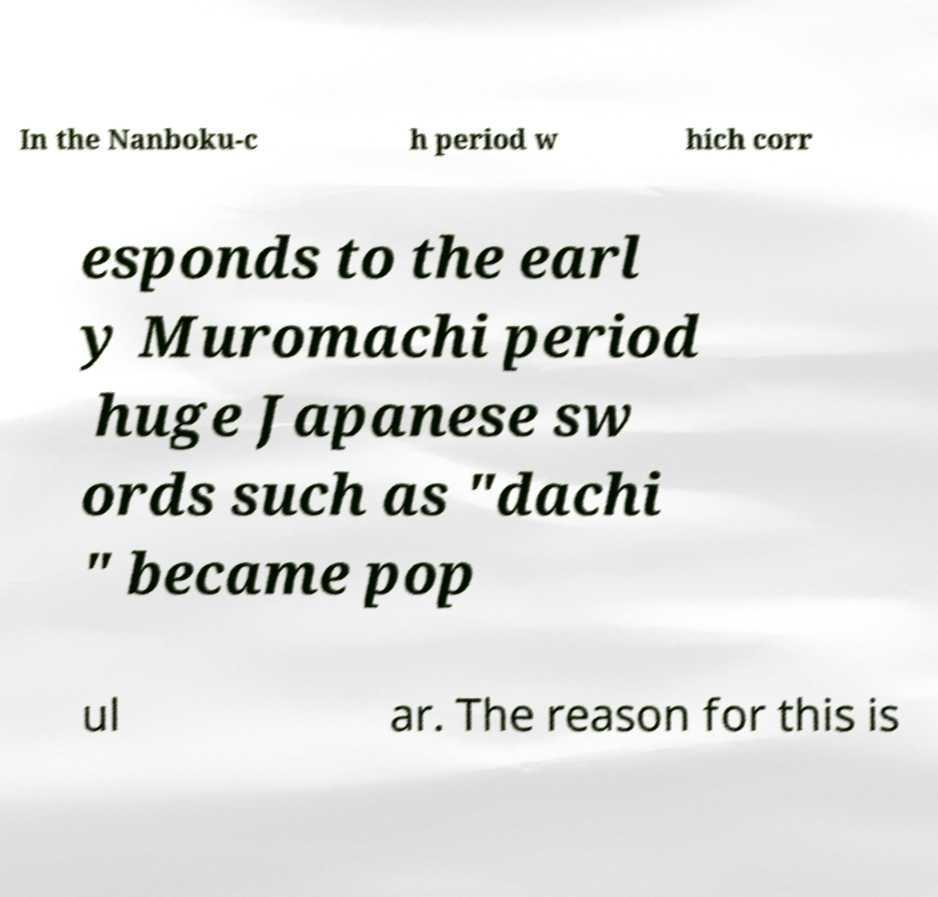Could you assist in decoding the text presented in this image and type it out clearly? In the Nanboku-c h period w hich corr esponds to the earl y Muromachi period huge Japanese sw ords such as "dachi " became pop ul ar. The reason for this is 